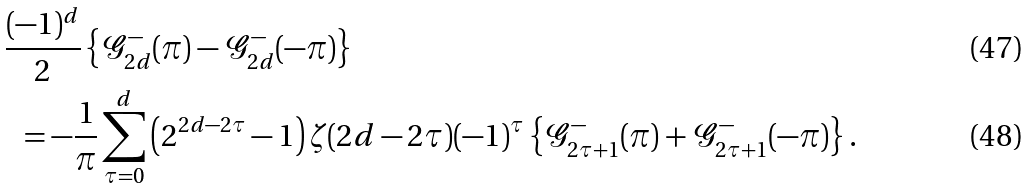<formula> <loc_0><loc_0><loc_500><loc_500>& \frac { ( - 1 ) ^ { d } } { 2 } \left \{ \mathcal { G } _ { 2 d } ^ { - } ( \pi ) - \mathcal { G } _ { 2 d } ^ { - } ( - \pi ) \right \} \\ & \ \ = - \frac { 1 } { \pi } \sum _ { \tau = 0 } ^ { d } \left ( 2 ^ { 2 d - 2 \tau } - 1 \right ) \zeta ( 2 d - 2 \tau ) ( - 1 ) ^ { \tau } \left \{ \mathcal { G } _ { 2 \tau + 1 } ^ { - } ( \pi ) + \mathcal { G } _ { 2 \tau + 1 } ^ { - } ( - \pi ) \right \} .</formula> 